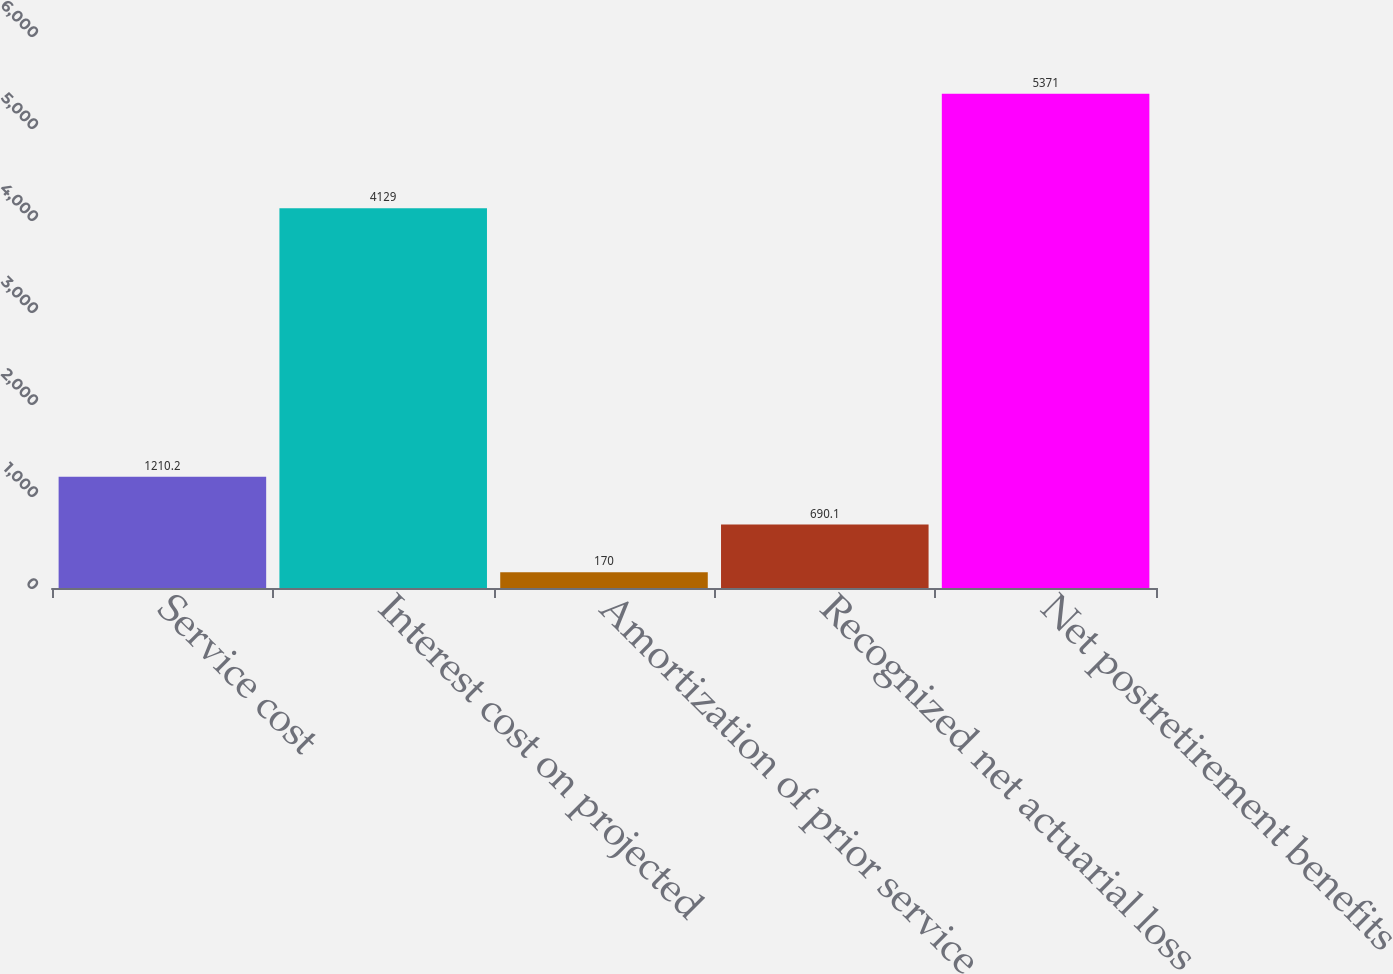Convert chart to OTSL. <chart><loc_0><loc_0><loc_500><loc_500><bar_chart><fcel>Service cost<fcel>Interest cost on projected<fcel>Amortization of prior service<fcel>Recognized net actuarial loss<fcel>Net postretirement benefits<nl><fcel>1210.2<fcel>4129<fcel>170<fcel>690.1<fcel>5371<nl></chart> 